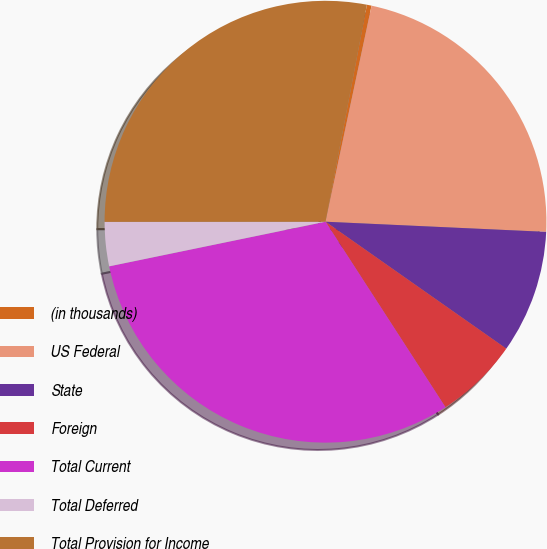Convert chart to OTSL. <chart><loc_0><loc_0><loc_500><loc_500><pie_chart><fcel>(in thousands)<fcel>US Federal<fcel>State<fcel>Foreign<fcel>Total Current<fcel>Total Deferred<fcel>Total Provision for Income<nl><fcel>0.34%<fcel>22.39%<fcel>9.01%<fcel>6.12%<fcel>30.9%<fcel>3.23%<fcel>28.01%<nl></chart> 